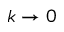Convert formula to latex. <formula><loc_0><loc_0><loc_500><loc_500>k \to 0</formula> 